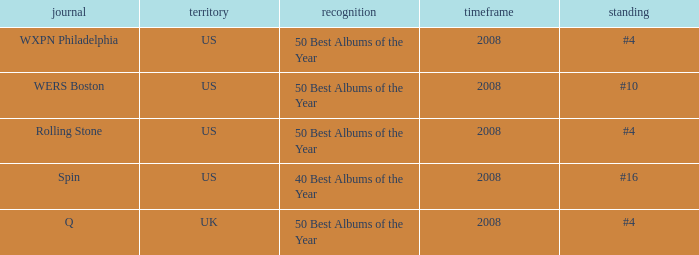Which issuance occurred in the uk? Q. 